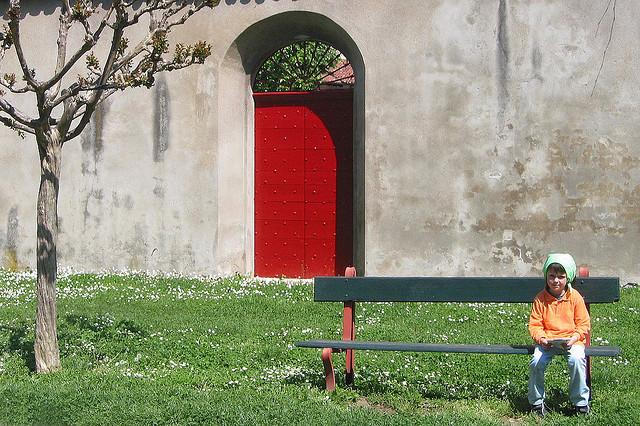Is the kid happy?
Keep it brief. Yes. Is it springtime?
Quick response, please. Yes. What color is the door?
Give a very brief answer. Red. 